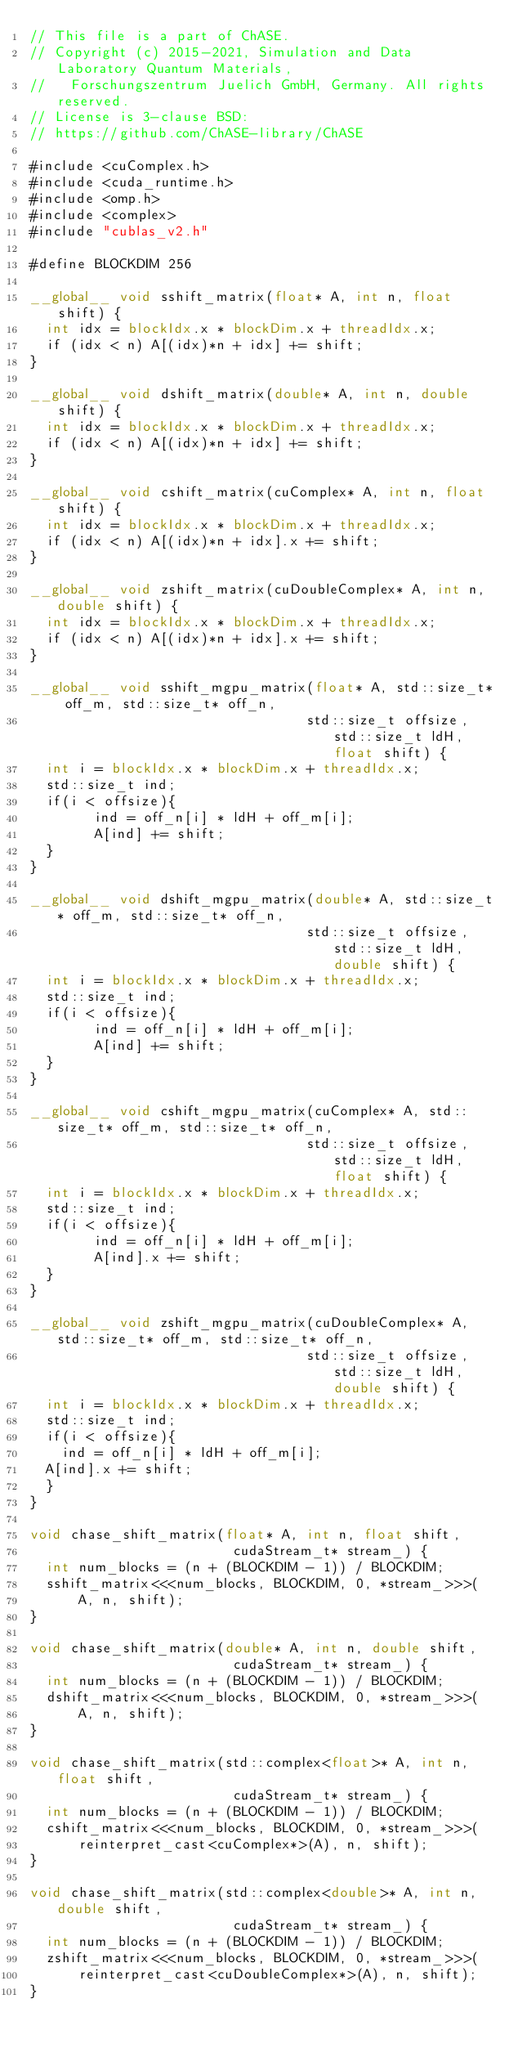<code> <loc_0><loc_0><loc_500><loc_500><_Cuda_>// This file is a part of ChASE.
// Copyright (c) 2015-2021, Simulation and Data Laboratory Quantum Materials, 
//   Forschungszentrum Juelich GmbH, Germany. All rights reserved.
// License is 3-clause BSD:
// https://github.com/ChASE-library/ChASE

#include <cuComplex.h>
#include <cuda_runtime.h>
#include <omp.h>
#include <complex>
#include "cublas_v2.h"

#define BLOCKDIM 256

__global__ void sshift_matrix(float* A, int n, float shift) {
  int idx = blockIdx.x * blockDim.x + threadIdx.x;
  if (idx < n) A[(idx)*n + idx] += shift;
}

__global__ void dshift_matrix(double* A, int n, double shift) {
  int idx = blockIdx.x * blockDim.x + threadIdx.x;
  if (idx < n) A[(idx)*n + idx] += shift;
}

__global__ void cshift_matrix(cuComplex* A, int n, float shift) {
  int idx = blockIdx.x * blockDim.x + threadIdx.x;
  if (idx < n) A[(idx)*n + idx].x += shift;
}

__global__ void zshift_matrix(cuDoubleComplex* A, int n, double shift) {
  int idx = blockIdx.x * blockDim.x + threadIdx.x;
  if (idx < n) A[(idx)*n + idx].x += shift;
}

__global__ void sshift_mgpu_matrix(float* A, std::size_t* off_m, std::size_t* off_n,
                                  std::size_t offsize, std::size_t ldH, float shift) {
  int i = blockIdx.x * blockDim.x + threadIdx.x;
  std::size_t ind;
  if(i < offsize){
        ind = off_n[i] * ldH + off_m[i];
        A[ind] += shift;
  }
}

__global__ void dshift_mgpu_matrix(double* A, std::size_t* off_m, std::size_t* off_n,
                                  std::size_t offsize, std::size_t ldH, double shift) {
  int i = blockIdx.x * blockDim.x + threadIdx.x;
  std::size_t ind;
  if(i < offsize){
        ind = off_n[i] * ldH + off_m[i];
        A[ind] += shift;
  }
}

__global__ void cshift_mgpu_matrix(cuComplex* A, std::size_t* off_m, std::size_t* off_n,
                                  std::size_t offsize, std::size_t ldH, float shift) {
  int i = blockIdx.x * blockDim.x + threadIdx.x;
  std::size_t ind;
  if(i < offsize){
        ind = off_n[i] * ldH + off_m[i];
        A[ind].x += shift;
  }
}

__global__ void zshift_mgpu_matrix(cuDoubleComplex* A, std::size_t* off_m, std::size_t* off_n,
                                  std::size_t offsize, std::size_t ldH, double shift) {
  int i = blockIdx.x * blockDim.x + threadIdx.x;
  std::size_t ind;
  if(i < offsize){
  	ind = off_n[i] * ldH + off_m[i];
	A[ind].x += shift;
  }
}

void chase_shift_matrix(float* A, int n, float shift,
                         cudaStream_t* stream_) {
  int num_blocks = (n + (BLOCKDIM - 1)) / BLOCKDIM;
  sshift_matrix<<<num_blocks, BLOCKDIM, 0, *stream_>>>(
      A, n, shift);
}

void chase_shift_matrix(double* A, int n, double shift,
                         cudaStream_t* stream_) {
  int num_blocks = (n + (BLOCKDIM - 1)) / BLOCKDIM;
  dshift_matrix<<<num_blocks, BLOCKDIM, 0, *stream_>>>(
      A, n, shift);
}

void chase_shift_matrix(std::complex<float>* A, int n, float shift,
                         cudaStream_t* stream_) {
  int num_blocks = (n + (BLOCKDIM - 1)) / BLOCKDIM;
  cshift_matrix<<<num_blocks, BLOCKDIM, 0, *stream_>>>(
      reinterpret_cast<cuComplex*>(A), n, shift);
}

void chase_shift_matrix(std::complex<double>* A, int n, double shift,
                         cudaStream_t* stream_) {
  int num_blocks = (n + (BLOCKDIM - 1)) / BLOCKDIM;
  zshift_matrix<<<num_blocks, BLOCKDIM, 0, *stream_>>>(
      reinterpret_cast<cuDoubleComplex*>(A), n, shift);
}
</code> 